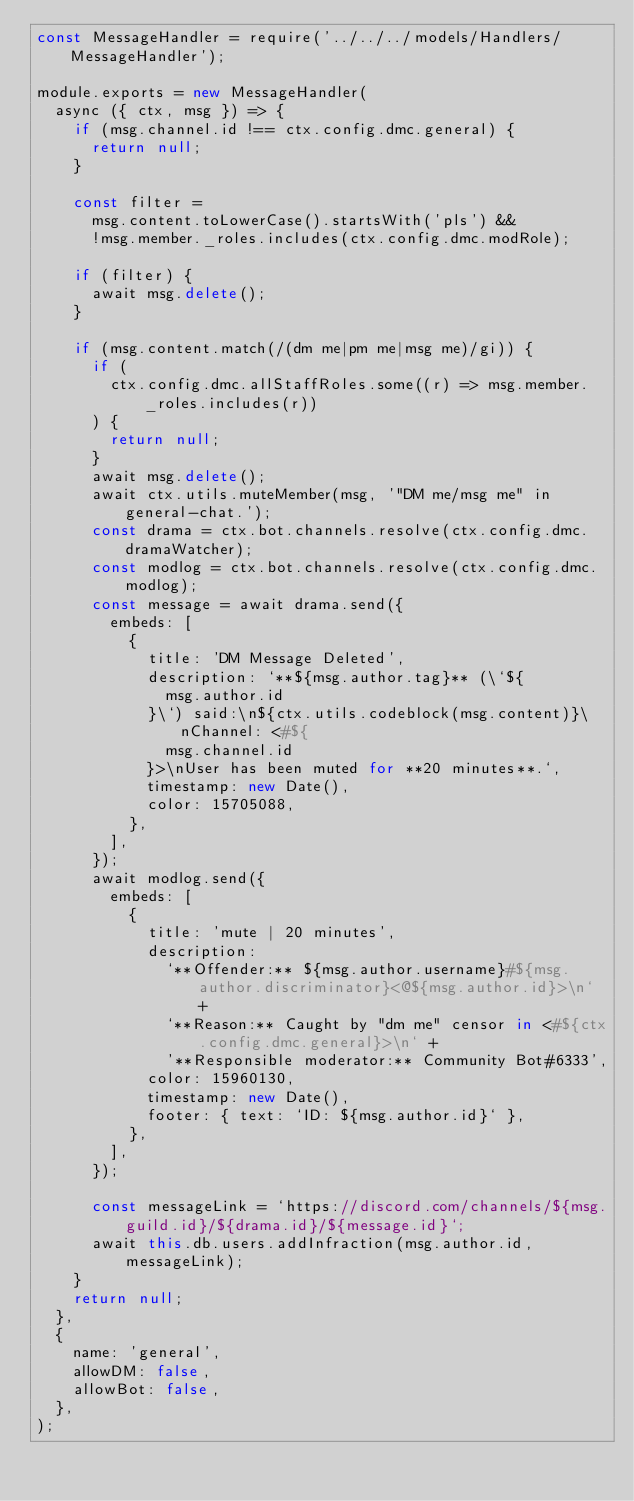<code> <loc_0><loc_0><loc_500><loc_500><_JavaScript_>const MessageHandler = require('../../../models/Handlers/MessageHandler');

module.exports = new MessageHandler(
  async ({ ctx, msg }) => {
    if (msg.channel.id !== ctx.config.dmc.general) {
      return null;
    }

    const filter =
      msg.content.toLowerCase().startsWith('pls') &&
      !msg.member._roles.includes(ctx.config.dmc.modRole);

    if (filter) {
      await msg.delete();
    }

    if (msg.content.match(/(dm me|pm me|msg me)/gi)) {
      if (
        ctx.config.dmc.allStaffRoles.some((r) => msg.member._roles.includes(r))
      ) {
        return null;
      }
      await msg.delete();
      await ctx.utils.muteMember(msg, '"DM me/msg me" in general-chat.');
      const drama = ctx.bot.channels.resolve(ctx.config.dmc.dramaWatcher);
      const modlog = ctx.bot.channels.resolve(ctx.config.dmc.modlog);
      const message = await drama.send({
        embeds: [
          {
            title: 'DM Message Deleted',
            description: `**${msg.author.tag}** (\`${
              msg.author.id
            }\`) said:\n${ctx.utils.codeblock(msg.content)}\nChannel: <#${
              msg.channel.id
            }>\nUser has been muted for **20 minutes**.`,
            timestamp: new Date(),
            color: 15705088,
          },
        ],
      });
      await modlog.send({
        embeds: [
          {
            title: 'mute | 20 minutes',
            description:
              `**Offender:** ${msg.author.username}#${msg.author.discriminator}<@${msg.author.id}>\n` +
              `**Reason:** Caught by "dm me" censor in <#${ctx.config.dmc.general}>\n` +
              '**Responsible moderator:** Community Bot#6333',
            color: 15960130,
            timestamp: new Date(),
            footer: { text: `ID: ${msg.author.id}` },
          },
        ],
      });

      const messageLink = `https://discord.com/channels/${msg.guild.id}/${drama.id}/${message.id}`;
      await this.db.users.addInfraction(msg.author.id, messageLink);
    }
    return null;
  },
  {
    name: 'general',
    allowDM: false,
    allowBot: false,
  },
);
</code> 